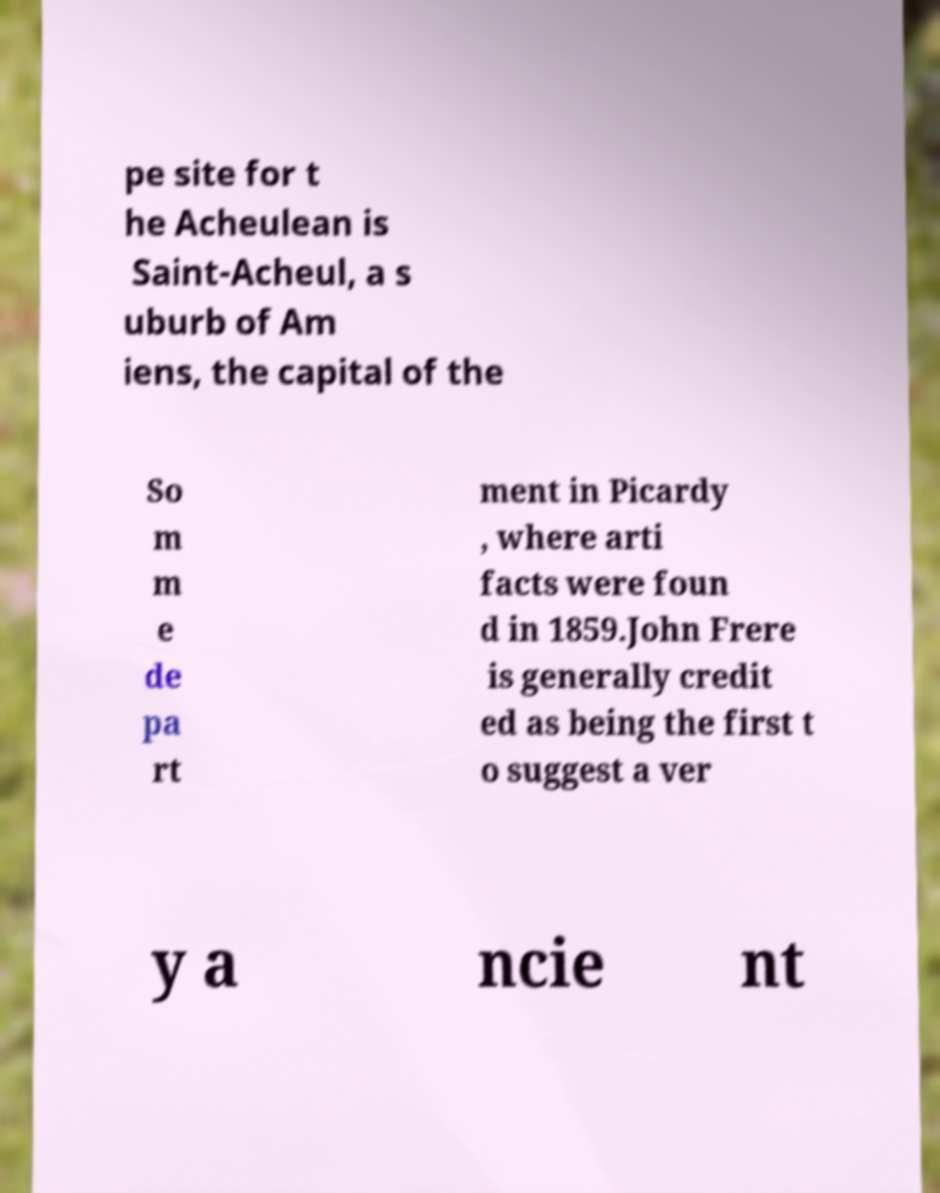Can you accurately transcribe the text from the provided image for me? pe site for t he Acheulean is Saint-Acheul, a s uburb of Am iens, the capital of the So m m e de pa rt ment in Picardy , where arti facts were foun d in 1859.John Frere is generally credit ed as being the first t o suggest a ver y a ncie nt 